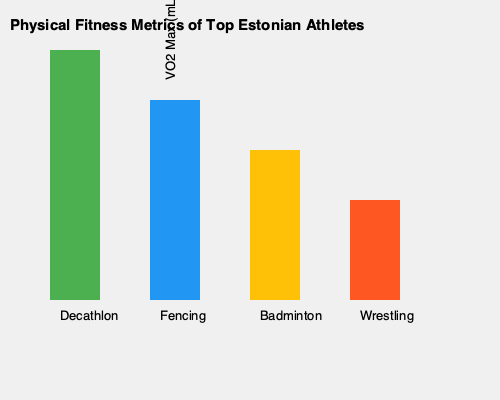Based on the graph showing VO2 max values for top Estonian athletes in different sports, which sport has the highest aerobic capacity, and approximately how much higher is it compared to the sport with the lowest VO2 max? To answer this question, we need to analyze the graph and follow these steps:

1. Identify the sport with the highest VO2 max:
   The tallest bar represents the highest VO2 max, which corresponds to Decathlon.

2. Identify the sport with the lowest VO2 max:
   The shortest bar represents the lowest VO2 max, which corresponds to Wrestling.

3. Estimate the VO2 max values:
   - Decathlon: The bar reaches the top of the graph, so it's approximately 70-75 mL/kg/min.
   - Wrestling: The bar is about 2/5 of the height of the Decathlon bar, so it's approximately 28-30 mL/kg/min.

4. Calculate the difference:
   $75 - 30 = 45$ mL/kg/min

Therefore, Decathlon athletes have the highest aerobic capacity, and it's approximately 45 mL/kg/min higher than Wrestling, which has the lowest VO2 max among the sports shown.
Answer: Decathlon; 45 mL/kg/min higher 